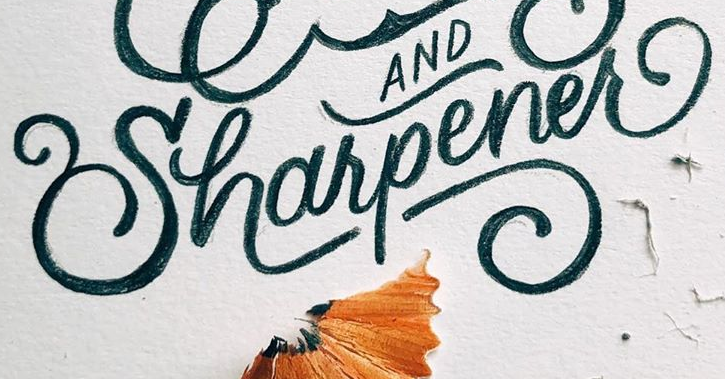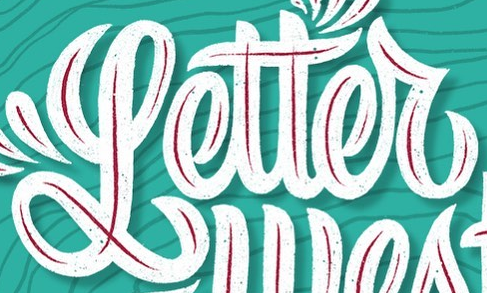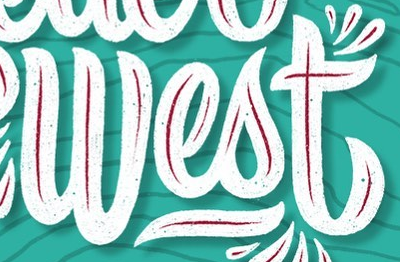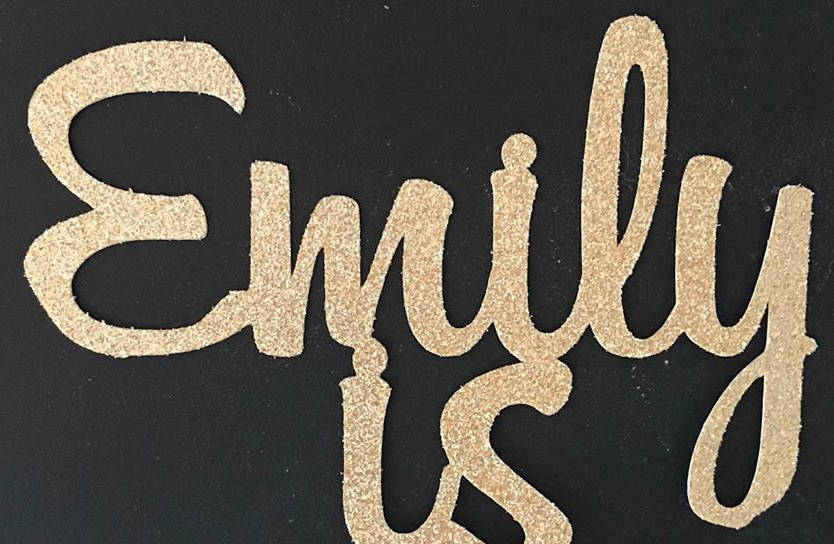Transcribe the words shown in these images in order, separated by a semicolon. Uharpener; Letter; West; Emily 